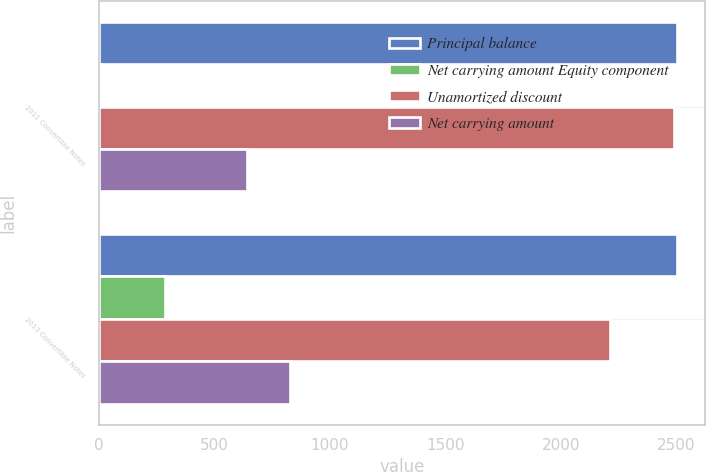Convert chart to OTSL. <chart><loc_0><loc_0><loc_500><loc_500><stacked_bar_chart><ecel><fcel>2011 Convertible Notes<fcel>2013 Convertible Notes<nl><fcel>Principal balance<fcel>2500<fcel>2500<nl><fcel>Net carrying amount Equity component<fcel>12<fcel>287<nl><fcel>Unamortized discount<fcel>2488<fcel>2213<nl><fcel>Net carrying amount<fcel>643<fcel>829<nl></chart> 